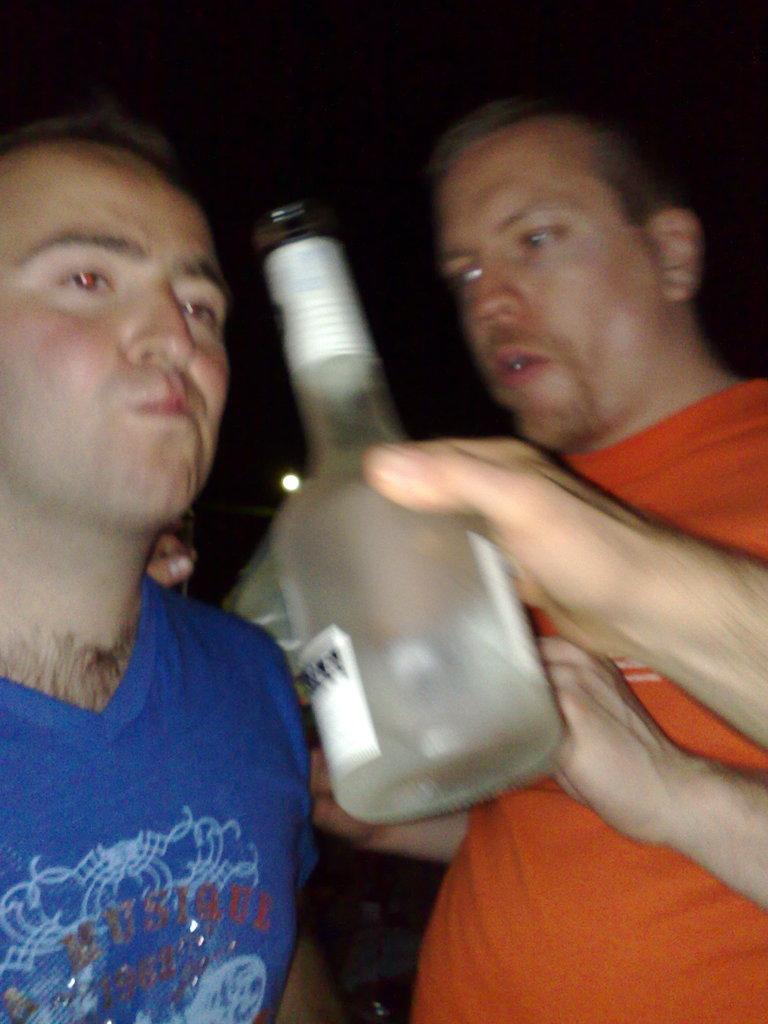Could you give a brief overview of what you see in this image? In the center of the picture there is a bottle. On the right a man in orange dress is stunning. On the left a man in blue dress is stunning. Background is dark. 